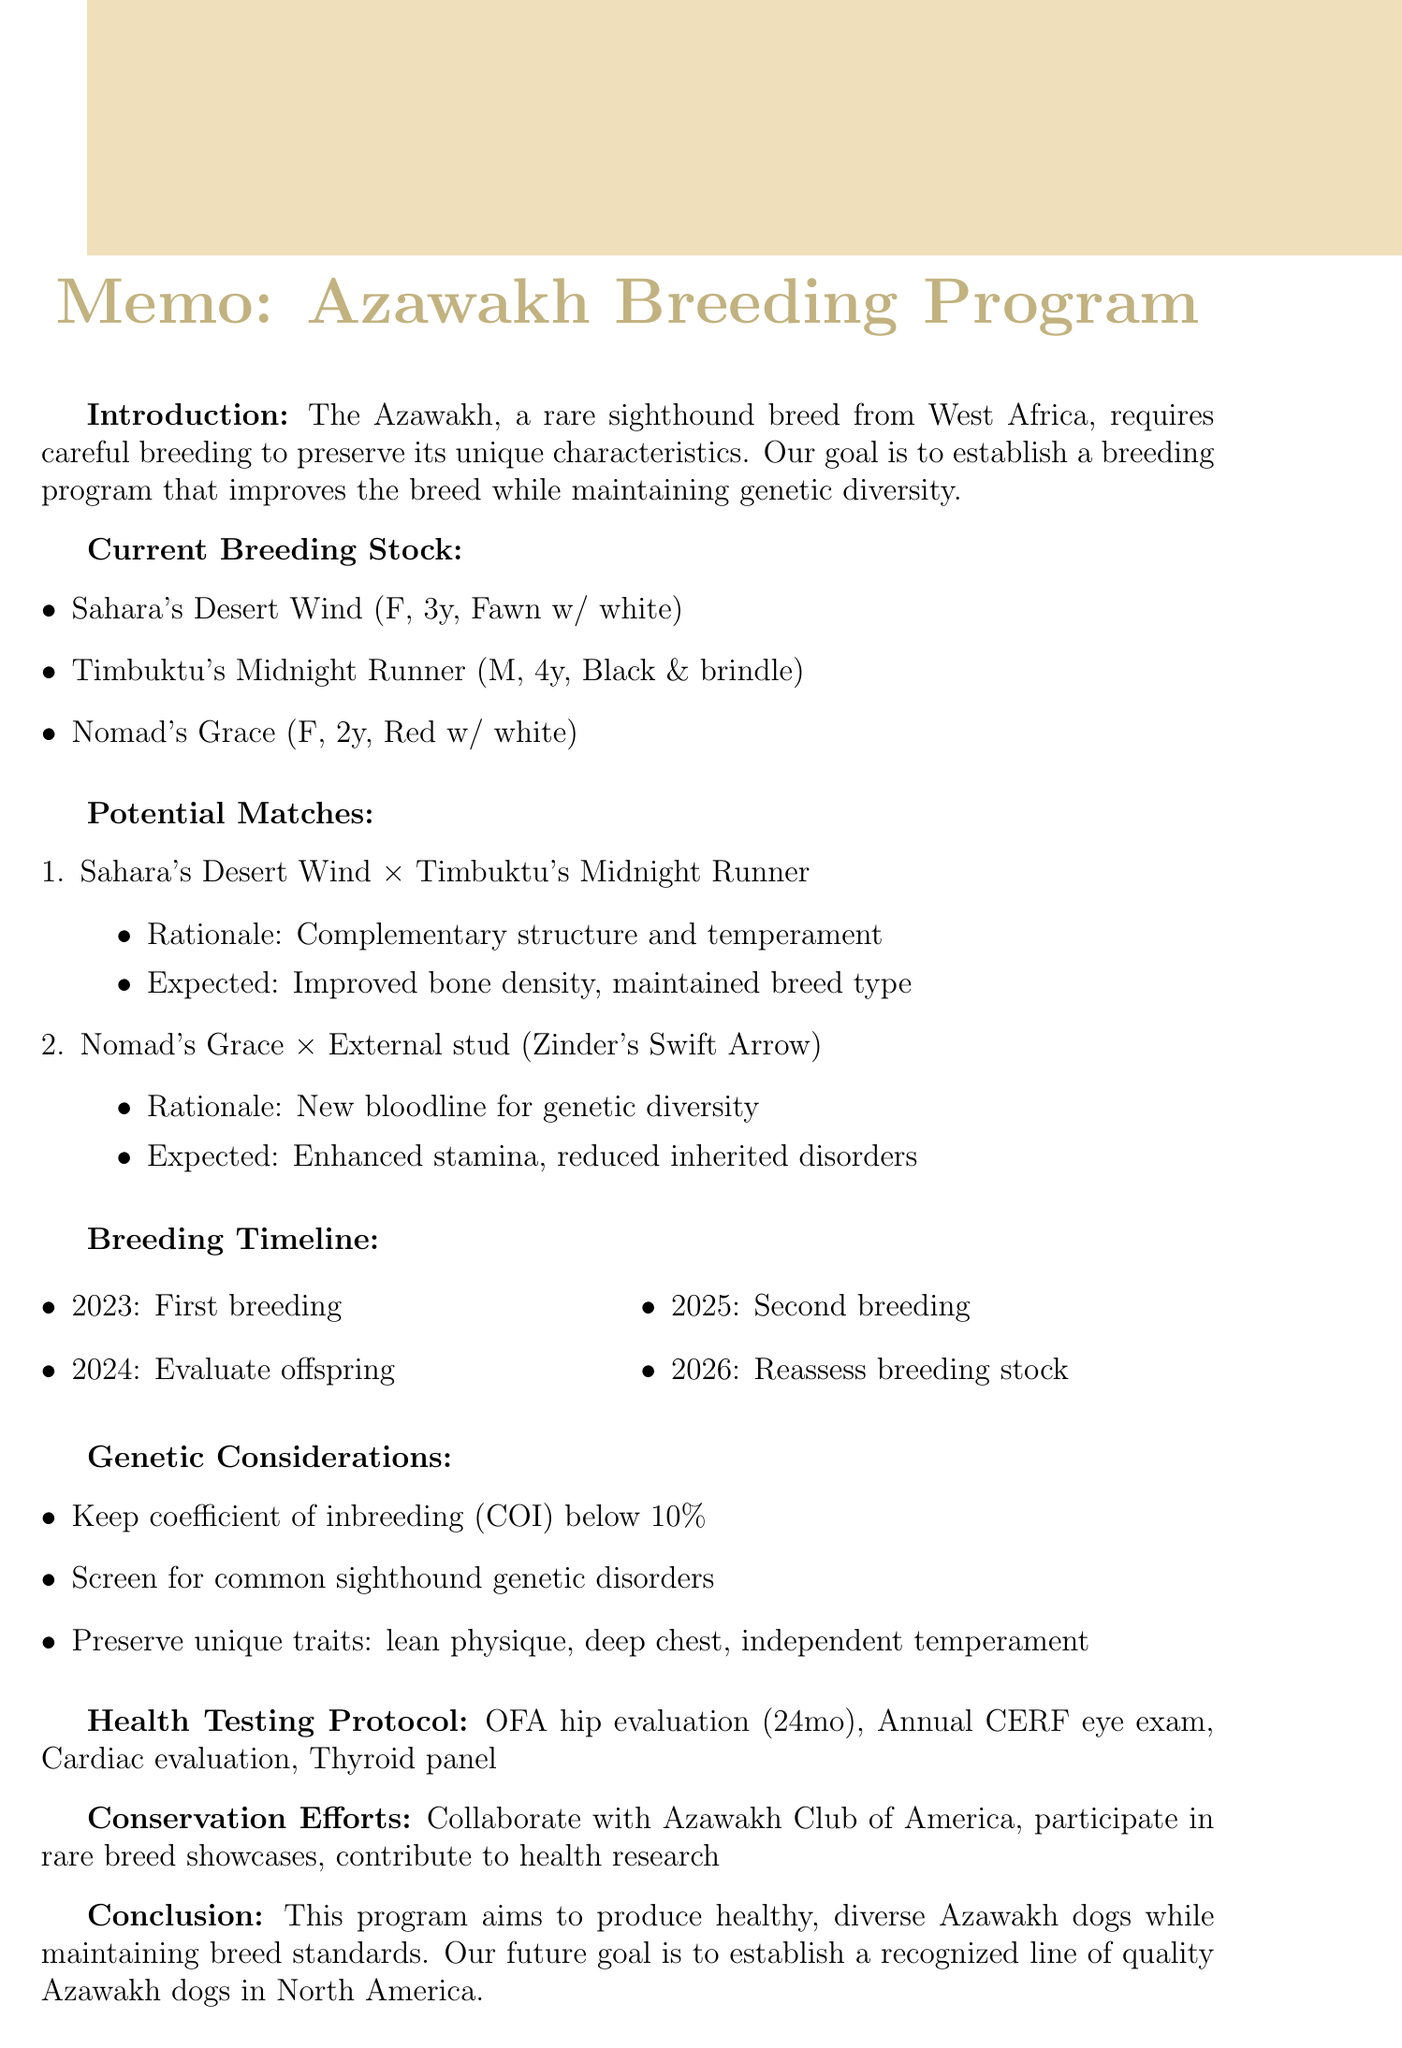what is the breed discussed in the memo? The breed discussed in the memo is Azawakh, which is specified as a rare sighthound originating from West Africa.
Answer: Azawakh what is the rationale for the first potential match? The rationale for the first potential match (Sahara's Desert Wind and Timbuktu's Midnight Runner) is that they have complementary body structures and temperaments.
Answer: Complementary body structures and temperaments what year is the first breeding scheduled? The first breeding is scheduled for 2023.
Answer: 2023 how many health clearances does Timbuktu's Midnight Runner have? Timbuktu's Midnight Runner has three health clearances listed: OFA hips, CERF eyes, and cardiac evaluation.
Answer: Three what is the expected outcome of introducing a new bloodline with Nomad's Grace? The expected outcome is enhanced stamina and reduced risk of inherited disorders by introducing new bloodline.
Answer: Enhanced stamina and reduced risk of inherited disorders what should the coefficient of inbreeding (COI) be kept below? The coefficient of inbreeding (COI) should be kept below 10%.
Answer: 10% who is the external stud mentioned for Nomad's Grace? The external stud mentioned for Nomad's Grace is Zinder's Swift Arrow.
Answer: Zinder's Swift Arrow what is the future goal of the breeding program? The future goal is to establish a recognized line of quality Azawakh dogs in North America.
Answer: Establish a recognized line of quality Azawakh dogs in North America 